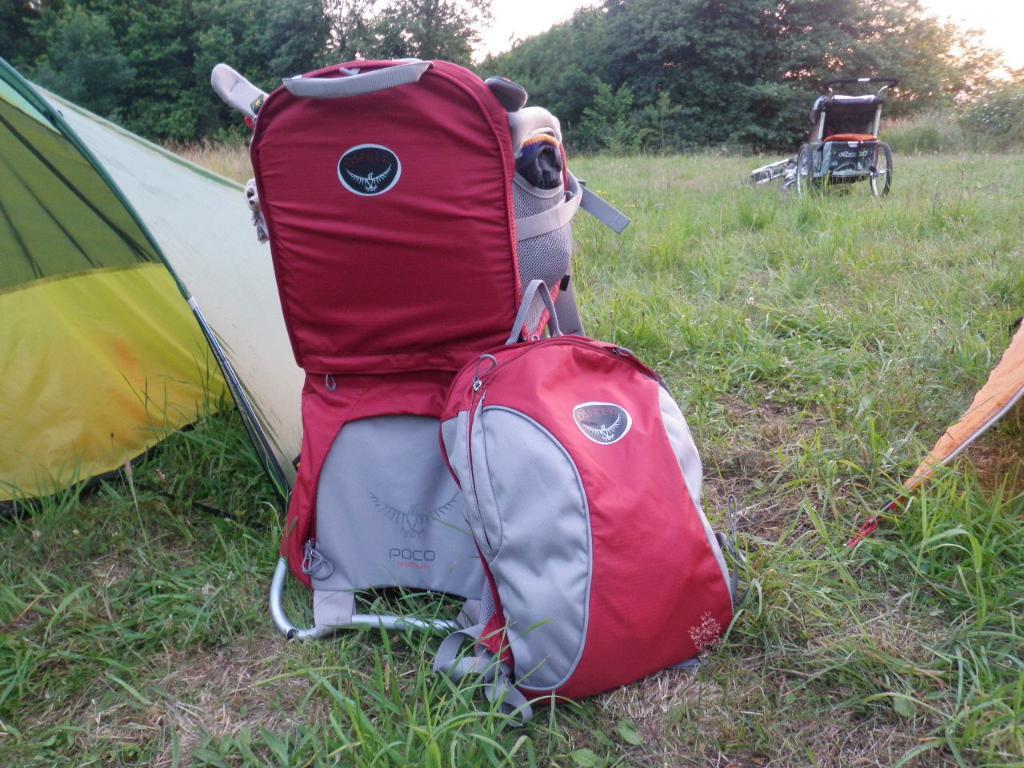Can you describe this image briefly? In the picture we can see a grass, trees, sky and some bags on the ground and we can also see the wheel chair. 